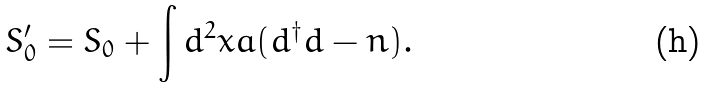Convert formula to latex. <formula><loc_0><loc_0><loc_500><loc_500>S ^ { \prime } _ { 0 } = S _ { 0 } + \int d ^ { 2 } x a ( d ^ { \dagger } d - n ) .</formula> 